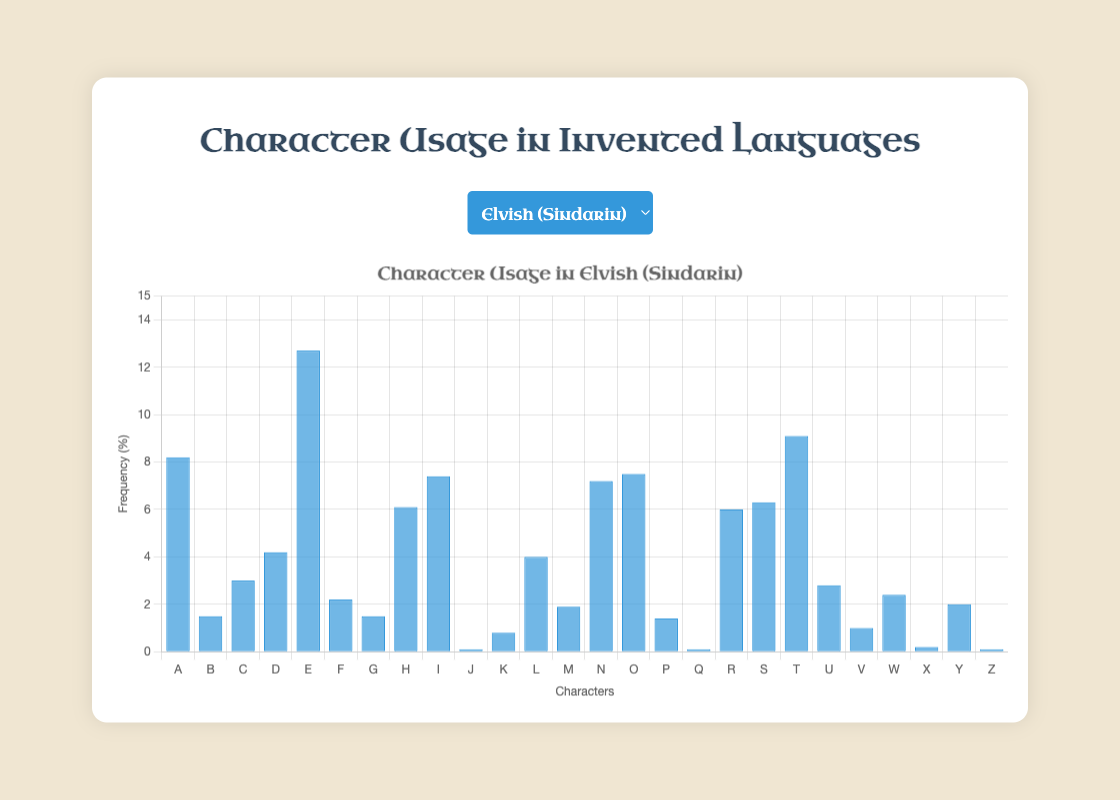Which character has the highest usage frequency in Elvish (Sindarin)? Look at the bar heights under the "Elvish (Sindarin)" label and identify the one that's tallest. The letter 'E' has the highest bar, representing 12.7%.
Answer: E What is the combined frequency of characters A and E in Dothraki? Add the frequencies of A (8.7) and E (11.1) from the Dothraki data. 8.7 + 11.1 = 19.8%.
Answer: 19.8 Comparing the character 'S' between Elvish (Sindarin) and Valyrian, which has a higher frequency? Observe the bar heights for 'S' in both languages. For Elvish (Sindarin), 'S' is 6.3%, and for Valyrian, 'S' is 6.5%. Valyrian has a slightly higher bar.
Answer: Valyrian How much greater is the frequency of 'T' in Elvish (Sindarin) than in Klingon? Subtract the frequency of 'T' in Klingon (6.2) from the frequency in Elvish (Sindarin) (9.1). 9.1 - 6.2 = 2.9%.
Answer: 2.9 What is the sum of frequencies for characters K and Q in all four languages? Sum the frequency of K and Q for each language:
Elvish (Sindarin): K (0.8) + Q (0.1) = 0.9
Dothraki: K (2.6) + Q (0.1) = 2.7
Klingon: K (4.5) + Q (1.2) = 5.7
Valyrian: K (0.6) + Q (0.1) = 0.7
Total sum: 0.9 + 2.7 + 5.7 + 0.7 = 10.0
Answer: 10.0 Which character has the lowest average frequency across all languages? Calculate the average frequency for each character across the four languages and identify the lowest.
J: (0.1 + 0.0 + 0.1 + 0.0) / 4 = 0.05 (lowest)
Sum and divide for others, noting J is consistently the smallest.
Answer: J 